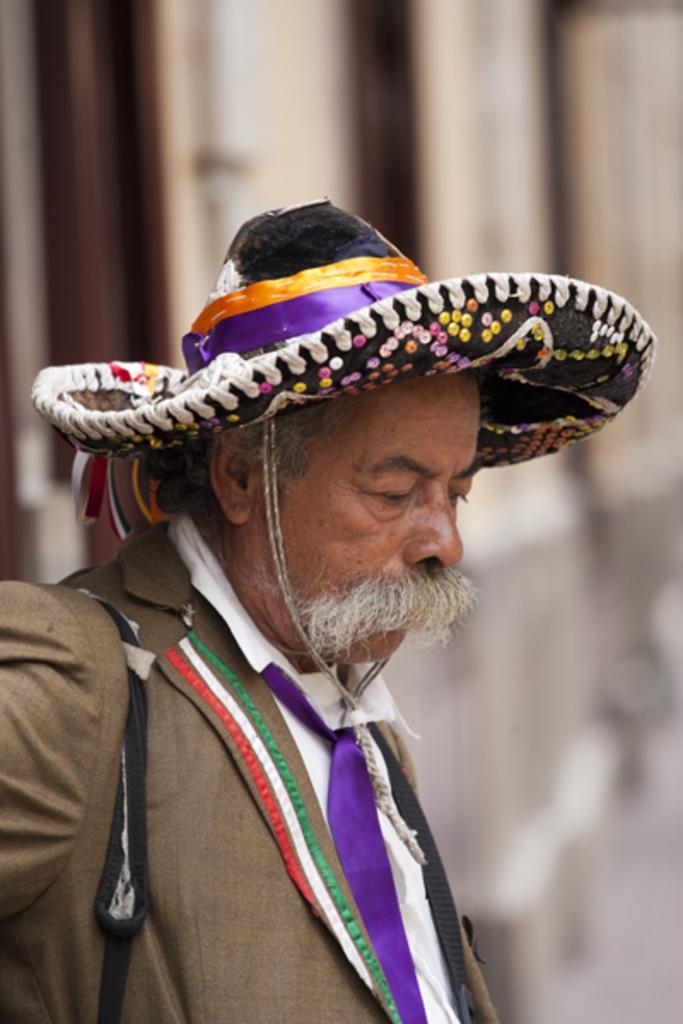Please provide a concise description of this image. In this image I can see a person standing, the person is wearing brown color blazer, purple color tie and the person is also wearing a cap and I can see blurred background. 